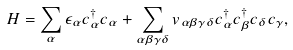<formula> <loc_0><loc_0><loc_500><loc_500>H = \sum _ { \alpha } \epsilon _ { \alpha } c _ { \alpha } ^ { \dagger } c _ { \alpha } + \sum _ { \alpha \beta \gamma \delta } v _ { \alpha \beta \gamma \delta } c _ { \alpha } ^ { \dagger } c _ { \beta } ^ { \dagger } c _ { \delta } c _ { \gamma } ,</formula> 